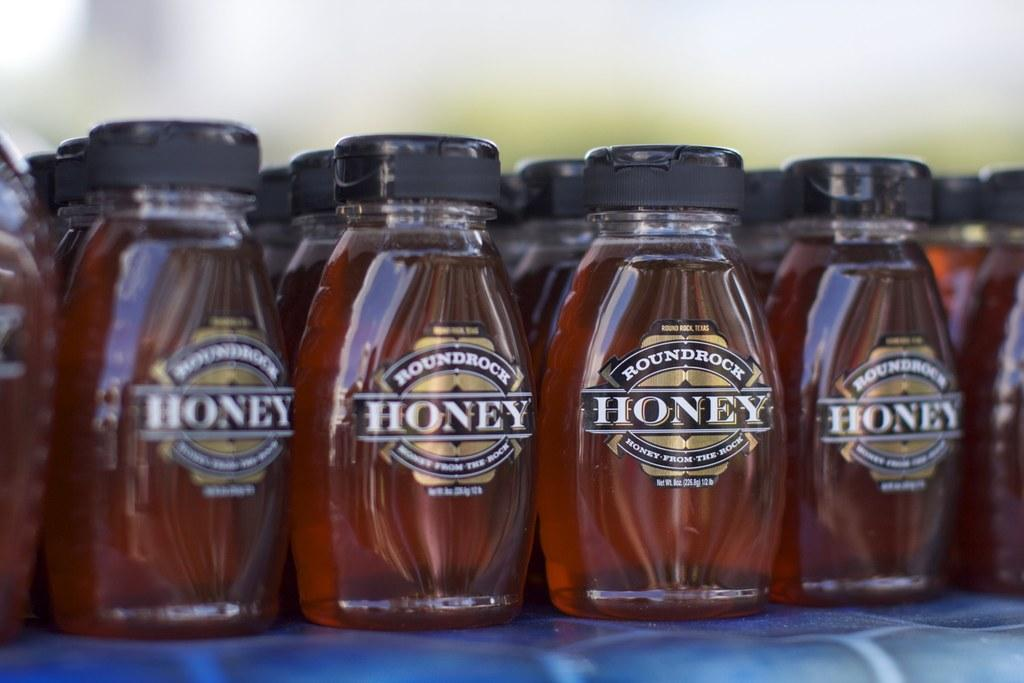<image>
Summarize the visual content of the image. Bottles of Roundrock honey are lined up in rows. 